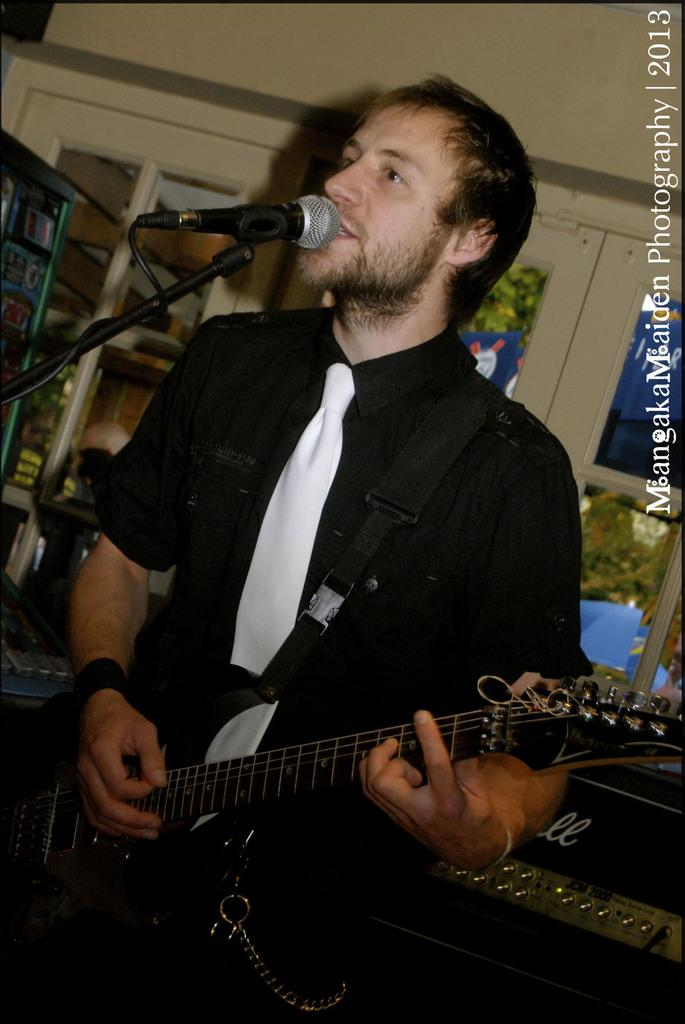What is the man in the image doing? The man is playing a guitar, singing, and using a microphone. What is the man wearing in the image? The man is wearing a black shirt and a white tie. What can be seen in the background of the image? There is a shelf in the background of the image. How many servants are present in the image? There are no servants present in the image. What type of peace is being promoted in the image? The image does not depict any peace-related content or message. 